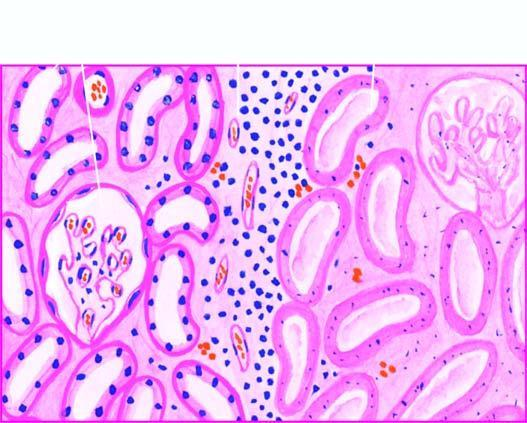do the nuclei show granular debris?
Answer the question using a single word or phrase. Yes 